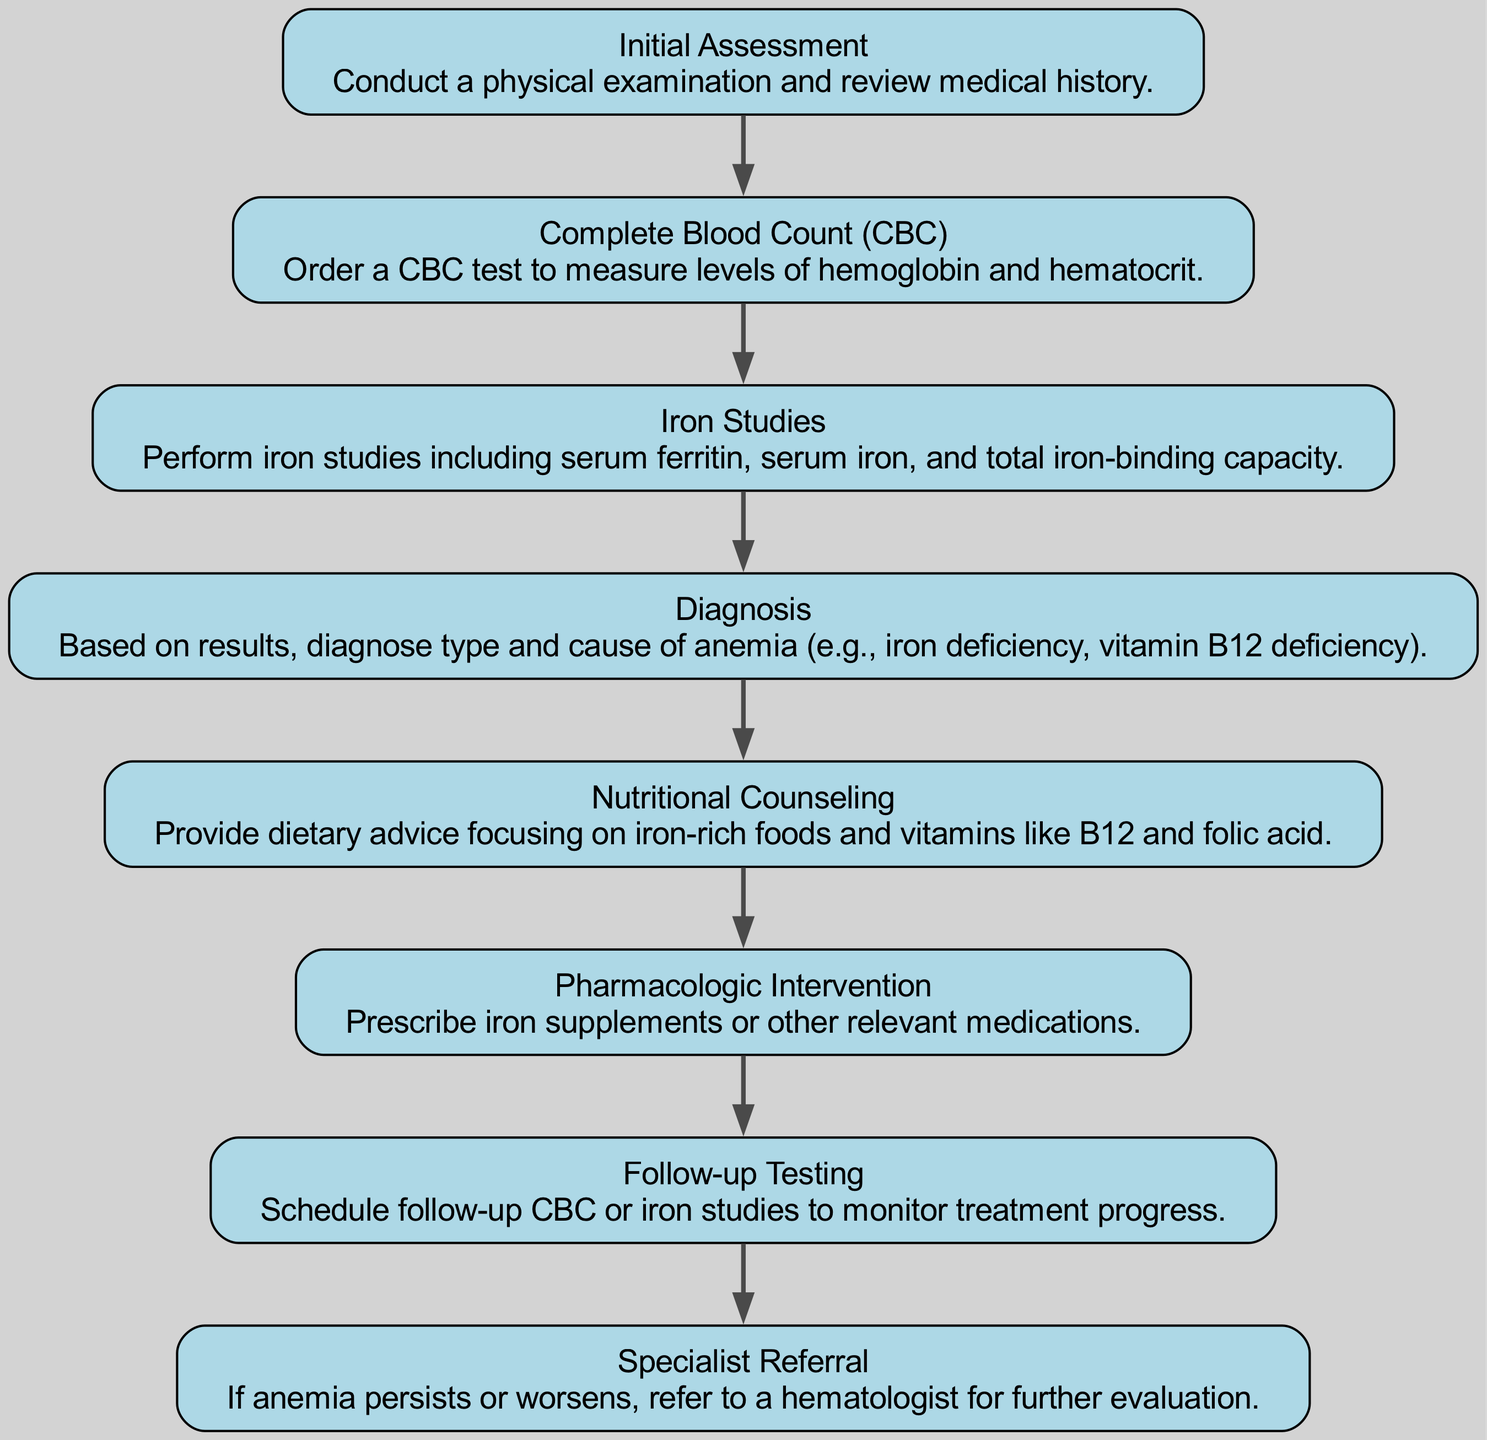What is the first step in the pathway? The first step is labeled "Initial Assessment," indicating the beginning of the workflow.
Answer: Initial Assessment How many total steps are in the diagram? There are a total of eight steps shown in the diagram, providing a comprehensive overview of the process.
Answer: 8 Which step follows the "Iron Studies"? The step that follows "Iron Studies" is "Diagnosis," indicating a progression from testing to interpreting results.
Answer: Diagnosis What type of specialist is a referral made to if anemia persists? A referral is made to a "hematologist" for further evaluation when anemia does not improve.
Answer: Hematologist What is provided in the "Nutritional Counseling" step? The step includes dietary advice focusing on iron-rich foods and vitamins like B12 and folic acid to address nutritional needs.
Answer: Dietary advice What is the common purpose of "Follow-up Testing"? "Follow-up Testing" is designed to monitor treatment progress, ensuring that the intervention is effective.
Answer: Monitor treatment progress What comes after the "Diagnosis" step? The step that comes after "Diagnosis" is "Nutritional Counseling," showing a plan for dealing with the identified issues.
Answer: Nutritional Counseling What does "Pharmacologic Intervention" involve? This step involves prescribing iron supplements or other relevant medications as part of the treatment plan.
Answer: Prescribing iron supplements What type of information is gathered during "Initial Assessment"? "Initial Assessment" collects physical examination data and reviews medical history to understand the patient's condition.
Answer: Physical examination and medical history 